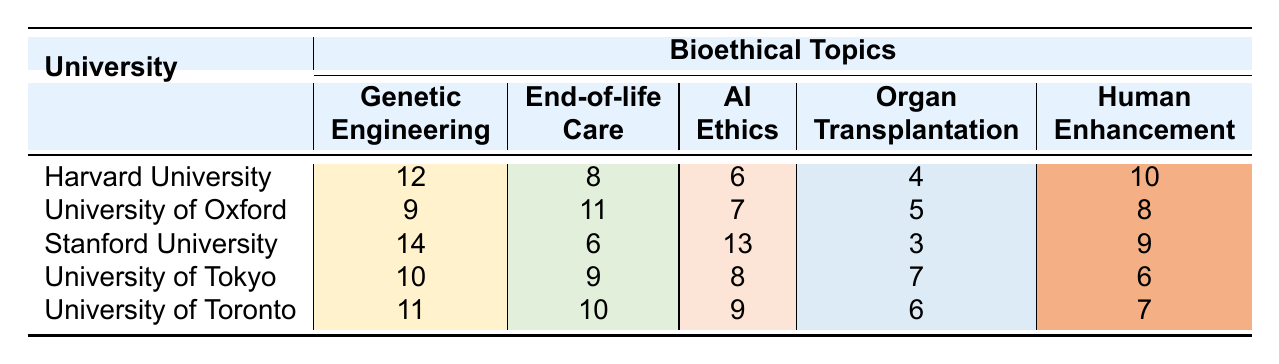What is the highest number of courses on Genetic Engineering among the universities? Looking at the Genetic Engineering column, the highest value is at Stanford University with 14 courses.
Answer: 14 Which university has the least number of courses in End-of-life Care? The least number of courses in End-of-life Care is at Stanford University with 6 courses.
Answer: Stanford University What is the total number of courses on Artificial Intelligence Ethics across all universities? Adding the values in the Artificial Intelligence Ethics column (6 + 7 + 13 + 8 + 9) gives 43 courses in total.
Answer: 43 Which bioethical topic has the highest total number of courses across all universities? Summing the values for each topic, Genetic Engineering has a total of 56 (12 + 9 + 14 + 10 + 11), End-of-life Care has 44 (8 + 11 + 6 + 9 + 10), AI Ethics has 43, Organ Transplantation has 25, and Human Enhancement has 40. Genetic Engineering has the highest total of 56.
Answer: Genetic Engineering Is the number of courses in Organ Transplantation at the University of Toronto greater than the number at Harvard University? The number of courses in Organ Transplantation at the University of Toronto is 6, while at Harvard University it is 4, so yes, Toronto has more courses.
Answer: Yes What is the average number of courses in Human Enhancement across the universities? Adding the number of courses in Human Enhancement (10 + 8 + 9 + 6 + 7 gives 40) and dividing by the number of universities (5) results in an average of 8.
Answer: 8 Which university offers the most balanced distribution of courses across all bioethical topics? Reviewing the distribution, the University of Oxford has values that are relatively close to each other: 9, 11, 7, 5, 8. Comparing the ranges of courses shows it is approximately balanced.
Answer: University of Oxford What bioethical topic does Harvard University rank lowest in? In terms of number of courses, Harvard University has the lowest count in Organ Transplantation with 4 courses.
Answer: Organ Transplantation How does the number of courses on Genetic Engineering at the University of Tokyo compare to that at the University of Toronto? At the University of Tokyo, there are 10 courses in Genetic Engineering, compared to 11 at the University of Toronto, meaning Toronto has slightly more.
Answer: University of Toronto has more courses If you were to focus solely on Artificial Intelligence Ethics, which university would provide the most courses? Stanford University offers the most courses in Artificial Intelligence Ethics with 13 courses, compared to other universities.
Answer: Stanford University 